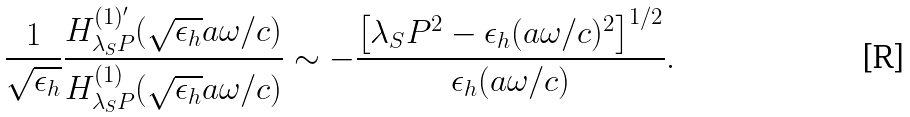Convert formula to latex. <formula><loc_0><loc_0><loc_500><loc_500>\frac { 1 } { \sqrt { \epsilon _ { h } } } \frac { H _ { \lambda _ { S } P } ^ { ( 1 ) ^ { \prime } } ( \sqrt { \epsilon _ { h } } a \omega / c ) } { H _ { \lambda _ { S } P } ^ { ( 1 ) } ( \sqrt { \epsilon _ { h } } a \omega / c ) } \sim - \frac { \left [ \lambda _ { S } P ^ { 2 } - \epsilon _ { h } ( a \omega / c ) ^ { 2 } \right ] ^ { 1 / 2 } } { \epsilon _ { h } ( a \omega / c ) } .</formula> 